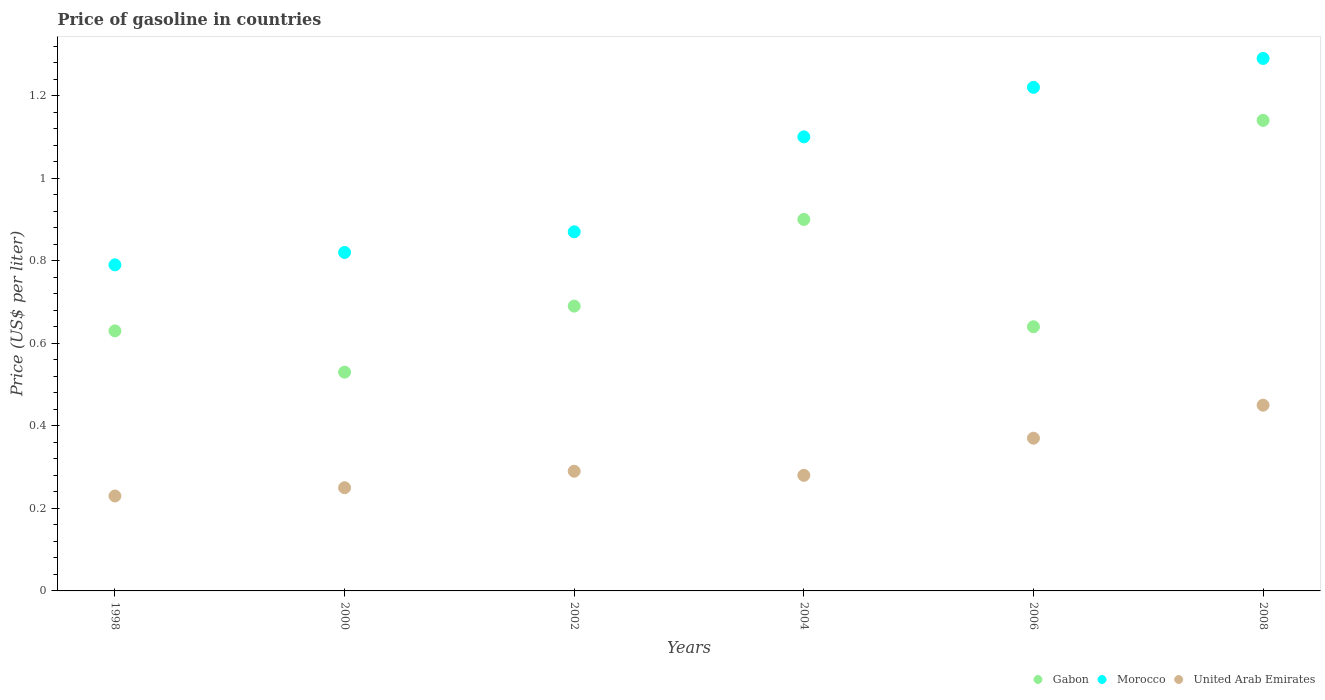How many different coloured dotlines are there?
Your response must be concise. 3. What is the price of gasoline in Gabon in 2008?
Offer a terse response. 1.14. Across all years, what is the maximum price of gasoline in Morocco?
Ensure brevity in your answer.  1.29. Across all years, what is the minimum price of gasoline in Morocco?
Offer a terse response. 0.79. What is the total price of gasoline in Gabon in the graph?
Offer a very short reply. 4.53. What is the difference between the price of gasoline in Morocco in 2006 and that in 2008?
Make the answer very short. -0.07. What is the difference between the price of gasoline in Morocco in 2002 and the price of gasoline in Gabon in 2008?
Provide a succinct answer. -0.27. In the year 2000, what is the difference between the price of gasoline in United Arab Emirates and price of gasoline in Gabon?
Your answer should be compact. -0.28. What is the ratio of the price of gasoline in United Arab Emirates in 2006 to that in 2008?
Offer a terse response. 0.82. Is the price of gasoline in Morocco in 1998 less than that in 2000?
Your response must be concise. Yes. Is the difference between the price of gasoline in United Arab Emirates in 2002 and 2008 greater than the difference between the price of gasoline in Gabon in 2002 and 2008?
Offer a terse response. Yes. What is the difference between the highest and the second highest price of gasoline in Gabon?
Your response must be concise. 0.24. In how many years, is the price of gasoline in Gabon greater than the average price of gasoline in Gabon taken over all years?
Give a very brief answer. 2. Is the price of gasoline in Morocco strictly less than the price of gasoline in Gabon over the years?
Your response must be concise. No. How many dotlines are there?
Ensure brevity in your answer.  3. How many years are there in the graph?
Offer a very short reply. 6. Does the graph contain any zero values?
Offer a terse response. No. Does the graph contain grids?
Your response must be concise. No. What is the title of the graph?
Your answer should be compact. Price of gasoline in countries. What is the label or title of the Y-axis?
Offer a very short reply. Price (US$ per liter). What is the Price (US$ per liter) of Gabon in 1998?
Offer a very short reply. 0.63. What is the Price (US$ per liter) in Morocco in 1998?
Make the answer very short. 0.79. What is the Price (US$ per liter) in United Arab Emirates in 1998?
Provide a short and direct response. 0.23. What is the Price (US$ per liter) in Gabon in 2000?
Make the answer very short. 0.53. What is the Price (US$ per liter) in Morocco in 2000?
Ensure brevity in your answer.  0.82. What is the Price (US$ per liter) of Gabon in 2002?
Make the answer very short. 0.69. What is the Price (US$ per liter) of Morocco in 2002?
Keep it short and to the point. 0.87. What is the Price (US$ per liter) in United Arab Emirates in 2002?
Offer a very short reply. 0.29. What is the Price (US$ per liter) of Gabon in 2004?
Offer a terse response. 0.9. What is the Price (US$ per liter) of United Arab Emirates in 2004?
Your answer should be very brief. 0.28. What is the Price (US$ per liter) in Gabon in 2006?
Your response must be concise. 0.64. What is the Price (US$ per liter) in Morocco in 2006?
Ensure brevity in your answer.  1.22. What is the Price (US$ per liter) in United Arab Emirates in 2006?
Ensure brevity in your answer.  0.37. What is the Price (US$ per liter) in Gabon in 2008?
Offer a terse response. 1.14. What is the Price (US$ per liter) of Morocco in 2008?
Your answer should be compact. 1.29. What is the Price (US$ per liter) in United Arab Emirates in 2008?
Provide a short and direct response. 0.45. Across all years, what is the maximum Price (US$ per liter) of Gabon?
Provide a succinct answer. 1.14. Across all years, what is the maximum Price (US$ per liter) of Morocco?
Ensure brevity in your answer.  1.29. Across all years, what is the maximum Price (US$ per liter) of United Arab Emirates?
Provide a short and direct response. 0.45. Across all years, what is the minimum Price (US$ per liter) in Gabon?
Provide a short and direct response. 0.53. Across all years, what is the minimum Price (US$ per liter) in Morocco?
Offer a very short reply. 0.79. Across all years, what is the minimum Price (US$ per liter) of United Arab Emirates?
Keep it short and to the point. 0.23. What is the total Price (US$ per liter) of Gabon in the graph?
Give a very brief answer. 4.53. What is the total Price (US$ per liter) in Morocco in the graph?
Your response must be concise. 6.09. What is the total Price (US$ per liter) of United Arab Emirates in the graph?
Provide a short and direct response. 1.87. What is the difference between the Price (US$ per liter) in Gabon in 1998 and that in 2000?
Your answer should be compact. 0.1. What is the difference between the Price (US$ per liter) in Morocco in 1998 and that in 2000?
Give a very brief answer. -0.03. What is the difference between the Price (US$ per liter) in United Arab Emirates in 1998 and that in 2000?
Provide a succinct answer. -0.02. What is the difference between the Price (US$ per liter) of Gabon in 1998 and that in 2002?
Make the answer very short. -0.06. What is the difference between the Price (US$ per liter) in Morocco in 1998 and that in 2002?
Your response must be concise. -0.08. What is the difference between the Price (US$ per liter) of United Arab Emirates in 1998 and that in 2002?
Your answer should be compact. -0.06. What is the difference between the Price (US$ per liter) of Gabon in 1998 and that in 2004?
Provide a succinct answer. -0.27. What is the difference between the Price (US$ per liter) in Morocco in 1998 and that in 2004?
Give a very brief answer. -0.31. What is the difference between the Price (US$ per liter) in Gabon in 1998 and that in 2006?
Provide a succinct answer. -0.01. What is the difference between the Price (US$ per liter) of Morocco in 1998 and that in 2006?
Offer a very short reply. -0.43. What is the difference between the Price (US$ per liter) of United Arab Emirates in 1998 and that in 2006?
Your response must be concise. -0.14. What is the difference between the Price (US$ per liter) in Gabon in 1998 and that in 2008?
Give a very brief answer. -0.51. What is the difference between the Price (US$ per liter) of Morocco in 1998 and that in 2008?
Give a very brief answer. -0.5. What is the difference between the Price (US$ per liter) in United Arab Emirates in 1998 and that in 2008?
Ensure brevity in your answer.  -0.22. What is the difference between the Price (US$ per liter) of Gabon in 2000 and that in 2002?
Offer a terse response. -0.16. What is the difference between the Price (US$ per liter) in Morocco in 2000 and that in 2002?
Keep it short and to the point. -0.05. What is the difference between the Price (US$ per liter) of United Arab Emirates in 2000 and that in 2002?
Offer a very short reply. -0.04. What is the difference between the Price (US$ per liter) in Gabon in 2000 and that in 2004?
Make the answer very short. -0.37. What is the difference between the Price (US$ per liter) in Morocco in 2000 and that in 2004?
Provide a short and direct response. -0.28. What is the difference between the Price (US$ per liter) in United Arab Emirates in 2000 and that in 2004?
Ensure brevity in your answer.  -0.03. What is the difference between the Price (US$ per liter) in Gabon in 2000 and that in 2006?
Your answer should be compact. -0.11. What is the difference between the Price (US$ per liter) of Morocco in 2000 and that in 2006?
Your answer should be compact. -0.4. What is the difference between the Price (US$ per liter) of United Arab Emirates in 2000 and that in 2006?
Your answer should be compact. -0.12. What is the difference between the Price (US$ per liter) in Gabon in 2000 and that in 2008?
Provide a succinct answer. -0.61. What is the difference between the Price (US$ per liter) in Morocco in 2000 and that in 2008?
Offer a very short reply. -0.47. What is the difference between the Price (US$ per liter) of Gabon in 2002 and that in 2004?
Ensure brevity in your answer.  -0.21. What is the difference between the Price (US$ per liter) in Morocco in 2002 and that in 2004?
Your response must be concise. -0.23. What is the difference between the Price (US$ per liter) in Gabon in 2002 and that in 2006?
Your response must be concise. 0.05. What is the difference between the Price (US$ per liter) in Morocco in 2002 and that in 2006?
Provide a succinct answer. -0.35. What is the difference between the Price (US$ per liter) of United Arab Emirates in 2002 and that in 2006?
Your answer should be very brief. -0.08. What is the difference between the Price (US$ per liter) in Gabon in 2002 and that in 2008?
Keep it short and to the point. -0.45. What is the difference between the Price (US$ per liter) of Morocco in 2002 and that in 2008?
Keep it short and to the point. -0.42. What is the difference between the Price (US$ per liter) of United Arab Emirates in 2002 and that in 2008?
Offer a very short reply. -0.16. What is the difference between the Price (US$ per liter) in Gabon in 2004 and that in 2006?
Keep it short and to the point. 0.26. What is the difference between the Price (US$ per liter) in Morocco in 2004 and that in 2006?
Offer a terse response. -0.12. What is the difference between the Price (US$ per liter) of United Arab Emirates in 2004 and that in 2006?
Your answer should be very brief. -0.09. What is the difference between the Price (US$ per liter) in Gabon in 2004 and that in 2008?
Ensure brevity in your answer.  -0.24. What is the difference between the Price (US$ per liter) of Morocco in 2004 and that in 2008?
Provide a succinct answer. -0.19. What is the difference between the Price (US$ per liter) of United Arab Emirates in 2004 and that in 2008?
Your answer should be compact. -0.17. What is the difference between the Price (US$ per liter) in Gabon in 2006 and that in 2008?
Offer a very short reply. -0.5. What is the difference between the Price (US$ per liter) in Morocco in 2006 and that in 2008?
Your answer should be very brief. -0.07. What is the difference between the Price (US$ per liter) of United Arab Emirates in 2006 and that in 2008?
Provide a succinct answer. -0.08. What is the difference between the Price (US$ per liter) in Gabon in 1998 and the Price (US$ per liter) in Morocco in 2000?
Your response must be concise. -0.19. What is the difference between the Price (US$ per liter) in Gabon in 1998 and the Price (US$ per liter) in United Arab Emirates in 2000?
Your answer should be compact. 0.38. What is the difference between the Price (US$ per liter) in Morocco in 1998 and the Price (US$ per liter) in United Arab Emirates in 2000?
Ensure brevity in your answer.  0.54. What is the difference between the Price (US$ per liter) in Gabon in 1998 and the Price (US$ per liter) in Morocco in 2002?
Your response must be concise. -0.24. What is the difference between the Price (US$ per liter) of Gabon in 1998 and the Price (US$ per liter) of United Arab Emirates in 2002?
Keep it short and to the point. 0.34. What is the difference between the Price (US$ per liter) in Gabon in 1998 and the Price (US$ per liter) in Morocco in 2004?
Keep it short and to the point. -0.47. What is the difference between the Price (US$ per liter) of Gabon in 1998 and the Price (US$ per liter) of United Arab Emirates in 2004?
Give a very brief answer. 0.35. What is the difference between the Price (US$ per liter) of Morocco in 1998 and the Price (US$ per liter) of United Arab Emirates in 2004?
Offer a very short reply. 0.51. What is the difference between the Price (US$ per liter) of Gabon in 1998 and the Price (US$ per liter) of Morocco in 2006?
Make the answer very short. -0.59. What is the difference between the Price (US$ per liter) of Gabon in 1998 and the Price (US$ per liter) of United Arab Emirates in 2006?
Your answer should be very brief. 0.26. What is the difference between the Price (US$ per liter) in Morocco in 1998 and the Price (US$ per liter) in United Arab Emirates in 2006?
Your response must be concise. 0.42. What is the difference between the Price (US$ per liter) of Gabon in 1998 and the Price (US$ per liter) of Morocco in 2008?
Make the answer very short. -0.66. What is the difference between the Price (US$ per liter) in Gabon in 1998 and the Price (US$ per liter) in United Arab Emirates in 2008?
Your response must be concise. 0.18. What is the difference between the Price (US$ per liter) of Morocco in 1998 and the Price (US$ per liter) of United Arab Emirates in 2008?
Offer a very short reply. 0.34. What is the difference between the Price (US$ per liter) in Gabon in 2000 and the Price (US$ per liter) in Morocco in 2002?
Keep it short and to the point. -0.34. What is the difference between the Price (US$ per liter) of Gabon in 2000 and the Price (US$ per liter) of United Arab Emirates in 2002?
Your response must be concise. 0.24. What is the difference between the Price (US$ per liter) in Morocco in 2000 and the Price (US$ per liter) in United Arab Emirates in 2002?
Provide a short and direct response. 0.53. What is the difference between the Price (US$ per liter) in Gabon in 2000 and the Price (US$ per liter) in Morocco in 2004?
Make the answer very short. -0.57. What is the difference between the Price (US$ per liter) of Morocco in 2000 and the Price (US$ per liter) of United Arab Emirates in 2004?
Offer a terse response. 0.54. What is the difference between the Price (US$ per liter) of Gabon in 2000 and the Price (US$ per liter) of Morocco in 2006?
Provide a short and direct response. -0.69. What is the difference between the Price (US$ per liter) in Gabon in 2000 and the Price (US$ per liter) in United Arab Emirates in 2006?
Ensure brevity in your answer.  0.16. What is the difference between the Price (US$ per liter) in Morocco in 2000 and the Price (US$ per liter) in United Arab Emirates in 2006?
Offer a very short reply. 0.45. What is the difference between the Price (US$ per liter) of Gabon in 2000 and the Price (US$ per liter) of Morocco in 2008?
Ensure brevity in your answer.  -0.76. What is the difference between the Price (US$ per liter) in Gabon in 2000 and the Price (US$ per liter) in United Arab Emirates in 2008?
Your answer should be compact. 0.08. What is the difference between the Price (US$ per liter) of Morocco in 2000 and the Price (US$ per liter) of United Arab Emirates in 2008?
Offer a terse response. 0.37. What is the difference between the Price (US$ per liter) of Gabon in 2002 and the Price (US$ per liter) of Morocco in 2004?
Your answer should be very brief. -0.41. What is the difference between the Price (US$ per liter) of Gabon in 2002 and the Price (US$ per liter) of United Arab Emirates in 2004?
Offer a terse response. 0.41. What is the difference between the Price (US$ per liter) of Morocco in 2002 and the Price (US$ per liter) of United Arab Emirates in 2004?
Offer a very short reply. 0.59. What is the difference between the Price (US$ per liter) in Gabon in 2002 and the Price (US$ per liter) in Morocco in 2006?
Provide a short and direct response. -0.53. What is the difference between the Price (US$ per liter) of Gabon in 2002 and the Price (US$ per liter) of United Arab Emirates in 2006?
Keep it short and to the point. 0.32. What is the difference between the Price (US$ per liter) of Morocco in 2002 and the Price (US$ per liter) of United Arab Emirates in 2006?
Provide a succinct answer. 0.5. What is the difference between the Price (US$ per liter) in Gabon in 2002 and the Price (US$ per liter) in Morocco in 2008?
Offer a terse response. -0.6. What is the difference between the Price (US$ per liter) in Gabon in 2002 and the Price (US$ per liter) in United Arab Emirates in 2008?
Offer a terse response. 0.24. What is the difference between the Price (US$ per liter) of Morocco in 2002 and the Price (US$ per liter) of United Arab Emirates in 2008?
Make the answer very short. 0.42. What is the difference between the Price (US$ per liter) in Gabon in 2004 and the Price (US$ per liter) in Morocco in 2006?
Your response must be concise. -0.32. What is the difference between the Price (US$ per liter) of Gabon in 2004 and the Price (US$ per liter) of United Arab Emirates in 2006?
Offer a terse response. 0.53. What is the difference between the Price (US$ per liter) in Morocco in 2004 and the Price (US$ per liter) in United Arab Emirates in 2006?
Keep it short and to the point. 0.73. What is the difference between the Price (US$ per liter) in Gabon in 2004 and the Price (US$ per liter) in Morocco in 2008?
Your answer should be very brief. -0.39. What is the difference between the Price (US$ per liter) of Gabon in 2004 and the Price (US$ per liter) of United Arab Emirates in 2008?
Give a very brief answer. 0.45. What is the difference between the Price (US$ per liter) in Morocco in 2004 and the Price (US$ per liter) in United Arab Emirates in 2008?
Provide a short and direct response. 0.65. What is the difference between the Price (US$ per liter) of Gabon in 2006 and the Price (US$ per liter) of Morocco in 2008?
Offer a terse response. -0.65. What is the difference between the Price (US$ per liter) of Gabon in 2006 and the Price (US$ per liter) of United Arab Emirates in 2008?
Your answer should be very brief. 0.19. What is the difference between the Price (US$ per liter) in Morocco in 2006 and the Price (US$ per liter) in United Arab Emirates in 2008?
Give a very brief answer. 0.77. What is the average Price (US$ per liter) in Gabon per year?
Provide a short and direct response. 0.76. What is the average Price (US$ per liter) of United Arab Emirates per year?
Offer a terse response. 0.31. In the year 1998, what is the difference between the Price (US$ per liter) in Gabon and Price (US$ per liter) in Morocco?
Make the answer very short. -0.16. In the year 1998, what is the difference between the Price (US$ per liter) in Gabon and Price (US$ per liter) in United Arab Emirates?
Offer a very short reply. 0.4. In the year 1998, what is the difference between the Price (US$ per liter) of Morocco and Price (US$ per liter) of United Arab Emirates?
Offer a very short reply. 0.56. In the year 2000, what is the difference between the Price (US$ per liter) in Gabon and Price (US$ per liter) in Morocco?
Your answer should be compact. -0.29. In the year 2000, what is the difference between the Price (US$ per liter) of Gabon and Price (US$ per liter) of United Arab Emirates?
Make the answer very short. 0.28. In the year 2000, what is the difference between the Price (US$ per liter) of Morocco and Price (US$ per liter) of United Arab Emirates?
Keep it short and to the point. 0.57. In the year 2002, what is the difference between the Price (US$ per liter) in Gabon and Price (US$ per liter) in Morocco?
Your answer should be compact. -0.18. In the year 2002, what is the difference between the Price (US$ per liter) in Gabon and Price (US$ per liter) in United Arab Emirates?
Offer a very short reply. 0.4. In the year 2002, what is the difference between the Price (US$ per liter) of Morocco and Price (US$ per liter) of United Arab Emirates?
Offer a terse response. 0.58. In the year 2004, what is the difference between the Price (US$ per liter) of Gabon and Price (US$ per liter) of Morocco?
Offer a terse response. -0.2. In the year 2004, what is the difference between the Price (US$ per liter) in Gabon and Price (US$ per liter) in United Arab Emirates?
Provide a succinct answer. 0.62. In the year 2004, what is the difference between the Price (US$ per liter) of Morocco and Price (US$ per liter) of United Arab Emirates?
Your answer should be very brief. 0.82. In the year 2006, what is the difference between the Price (US$ per liter) in Gabon and Price (US$ per liter) in Morocco?
Make the answer very short. -0.58. In the year 2006, what is the difference between the Price (US$ per liter) of Gabon and Price (US$ per liter) of United Arab Emirates?
Keep it short and to the point. 0.27. In the year 2008, what is the difference between the Price (US$ per liter) of Gabon and Price (US$ per liter) of Morocco?
Provide a succinct answer. -0.15. In the year 2008, what is the difference between the Price (US$ per liter) of Gabon and Price (US$ per liter) of United Arab Emirates?
Provide a short and direct response. 0.69. In the year 2008, what is the difference between the Price (US$ per liter) in Morocco and Price (US$ per liter) in United Arab Emirates?
Your answer should be very brief. 0.84. What is the ratio of the Price (US$ per liter) in Gabon in 1998 to that in 2000?
Make the answer very short. 1.19. What is the ratio of the Price (US$ per liter) of Morocco in 1998 to that in 2000?
Make the answer very short. 0.96. What is the ratio of the Price (US$ per liter) in Gabon in 1998 to that in 2002?
Make the answer very short. 0.91. What is the ratio of the Price (US$ per liter) of Morocco in 1998 to that in 2002?
Ensure brevity in your answer.  0.91. What is the ratio of the Price (US$ per liter) of United Arab Emirates in 1998 to that in 2002?
Provide a succinct answer. 0.79. What is the ratio of the Price (US$ per liter) in Morocco in 1998 to that in 2004?
Offer a terse response. 0.72. What is the ratio of the Price (US$ per liter) of United Arab Emirates in 1998 to that in 2004?
Offer a terse response. 0.82. What is the ratio of the Price (US$ per liter) of Gabon in 1998 to that in 2006?
Your answer should be compact. 0.98. What is the ratio of the Price (US$ per liter) in Morocco in 1998 to that in 2006?
Your answer should be compact. 0.65. What is the ratio of the Price (US$ per liter) of United Arab Emirates in 1998 to that in 2006?
Give a very brief answer. 0.62. What is the ratio of the Price (US$ per liter) in Gabon in 1998 to that in 2008?
Offer a very short reply. 0.55. What is the ratio of the Price (US$ per liter) of Morocco in 1998 to that in 2008?
Provide a succinct answer. 0.61. What is the ratio of the Price (US$ per liter) in United Arab Emirates in 1998 to that in 2008?
Your response must be concise. 0.51. What is the ratio of the Price (US$ per liter) in Gabon in 2000 to that in 2002?
Your response must be concise. 0.77. What is the ratio of the Price (US$ per liter) in Morocco in 2000 to that in 2002?
Offer a terse response. 0.94. What is the ratio of the Price (US$ per liter) of United Arab Emirates in 2000 to that in 2002?
Give a very brief answer. 0.86. What is the ratio of the Price (US$ per liter) of Gabon in 2000 to that in 2004?
Ensure brevity in your answer.  0.59. What is the ratio of the Price (US$ per liter) in Morocco in 2000 to that in 2004?
Offer a very short reply. 0.75. What is the ratio of the Price (US$ per liter) in United Arab Emirates in 2000 to that in 2004?
Offer a terse response. 0.89. What is the ratio of the Price (US$ per liter) of Gabon in 2000 to that in 2006?
Make the answer very short. 0.83. What is the ratio of the Price (US$ per liter) of Morocco in 2000 to that in 2006?
Keep it short and to the point. 0.67. What is the ratio of the Price (US$ per liter) of United Arab Emirates in 2000 to that in 2006?
Offer a very short reply. 0.68. What is the ratio of the Price (US$ per liter) in Gabon in 2000 to that in 2008?
Your response must be concise. 0.46. What is the ratio of the Price (US$ per liter) of Morocco in 2000 to that in 2008?
Keep it short and to the point. 0.64. What is the ratio of the Price (US$ per liter) in United Arab Emirates in 2000 to that in 2008?
Offer a very short reply. 0.56. What is the ratio of the Price (US$ per liter) of Gabon in 2002 to that in 2004?
Ensure brevity in your answer.  0.77. What is the ratio of the Price (US$ per liter) of Morocco in 2002 to that in 2004?
Ensure brevity in your answer.  0.79. What is the ratio of the Price (US$ per liter) of United Arab Emirates in 2002 to that in 2004?
Give a very brief answer. 1.04. What is the ratio of the Price (US$ per liter) in Gabon in 2002 to that in 2006?
Make the answer very short. 1.08. What is the ratio of the Price (US$ per liter) in Morocco in 2002 to that in 2006?
Provide a short and direct response. 0.71. What is the ratio of the Price (US$ per liter) of United Arab Emirates in 2002 to that in 2006?
Give a very brief answer. 0.78. What is the ratio of the Price (US$ per liter) in Gabon in 2002 to that in 2008?
Make the answer very short. 0.61. What is the ratio of the Price (US$ per liter) of Morocco in 2002 to that in 2008?
Provide a succinct answer. 0.67. What is the ratio of the Price (US$ per liter) in United Arab Emirates in 2002 to that in 2008?
Your answer should be very brief. 0.64. What is the ratio of the Price (US$ per liter) of Gabon in 2004 to that in 2006?
Your answer should be very brief. 1.41. What is the ratio of the Price (US$ per liter) in Morocco in 2004 to that in 2006?
Your answer should be compact. 0.9. What is the ratio of the Price (US$ per liter) of United Arab Emirates in 2004 to that in 2006?
Give a very brief answer. 0.76. What is the ratio of the Price (US$ per liter) of Gabon in 2004 to that in 2008?
Make the answer very short. 0.79. What is the ratio of the Price (US$ per liter) of Morocco in 2004 to that in 2008?
Offer a terse response. 0.85. What is the ratio of the Price (US$ per liter) in United Arab Emirates in 2004 to that in 2008?
Offer a terse response. 0.62. What is the ratio of the Price (US$ per liter) of Gabon in 2006 to that in 2008?
Ensure brevity in your answer.  0.56. What is the ratio of the Price (US$ per liter) in Morocco in 2006 to that in 2008?
Give a very brief answer. 0.95. What is the ratio of the Price (US$ per liter) of United Arab Emirates in 2006 to that in 2008?
Ensure brevity in your answer.  0.82. What is the difference between the highest and the second highest Price (US$ per liter) of Gabon?
Your answer should be compact. 0.24. What is the difference between the highest and the second highest Price (US$ per liter) in Morocco?
Provide a short and direct response. 0.07. What is the difference between the highest and the lowest Price (US$ per liter) of Gabon?
Ensure brevity in your answer.  0.61. What is the difference between the highest and the lowest Price (US$ per liter) in United Arab Emirates?
Offer a terse response. 0.22. 